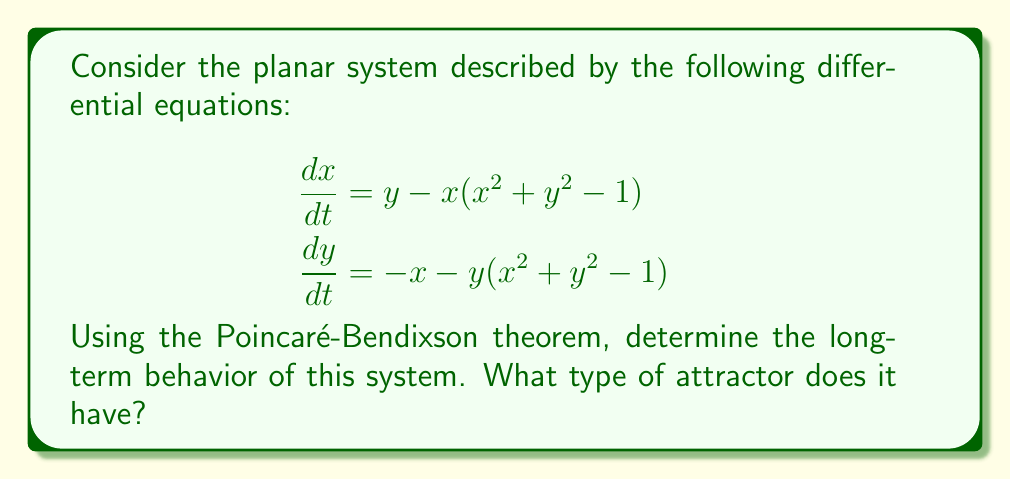Teach me how to tackle this problem. Let's approach this step-by-step:

1) First, we need to identify the critical points of the system. Set both equations to zero:

   $$\begin{aligned}
   y - x(x^2 + y^2 - 1) &= 0 \\
   -x - y(x^2 + y^2 - 1) &= 0
   \end{aligned}$$

2) Solving this, we find two critical points: $(0,0)$ and any point on the unit circle $x^2 + y^2 = 1$.

3) Now, let's consider the behavior of the system in polar coordinates. Let $r^2 = x^2 + y^2$. Then:

   $$\begin{aligned}
   \frac{d}{dt}(r^2) &= 2x\frac{dx}{dt} + 2y\frac{dy}{dt} \\
   &= 2x(y - x(r^2 - 1)) + 2y(-x - y(r^2 - 1)) \\
   &= -2r^2(r^2 - 1)
   \end{aligned}$$

4) From this, we can see that:
   - When $r < 1$, $\frac{d}{dt}(r^2) > 0$, so $r$ increases.
   - When $r > 1$, $\frac{d}{dt}(r^2) < 0$, so $r$ decreases.
   - When $r = 1$, $\frac{d}{dt}(r^2) = 0$, so $r$ remains constant.

5) This means that trajectories spiral away from the origin and towards the unit circle.

6) The unit circle itself is an orbit of the system (as we can see from step 2).

7) Now, we can apply the Poincaré-Bendixson theorem. It states that for a bounded planar system, if a trajectory enters and remains in a closed, bounded region that contains no fixed points, then the trajectory must approach a closed orbit.

8) In our case, any trajectory starting outside the origin will eventually enter and remain in the annular region between two circles centered at the origin, one with radius slightly less than 1 and one with radius slightly more than 1. This region contains no fixed points.

9) Therefore, by the Poincaré-Bendixson theorem, all trajectories (except the unstable equilibrium at the origin) must approach the closed orbit on the unit circle.
Answer: Limit cycle (unit circle) 